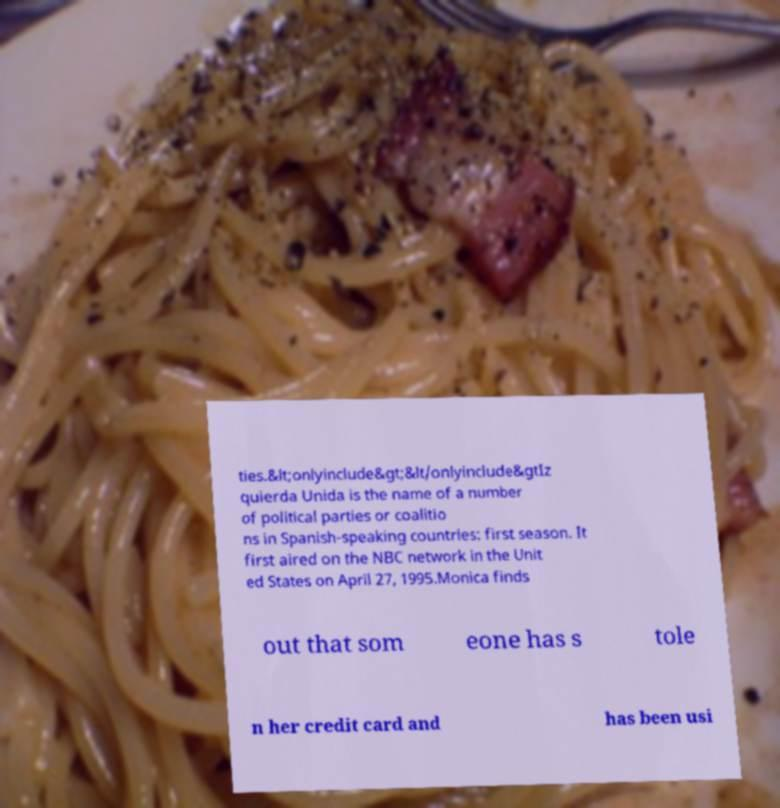Could you assist in decoding the text presented in this image and type it out clearly? ties.&lt;onlyinclude&gt;&lt/onlyinclude&gtIz quierda Unida is the name of a number of political parties or coalitio ns in Spanish-speaking countries: first season. It first aired on the NBC network in the Unit ed States on April 27, 1995.Monica finds out that som eone has s tole n her credit card and has been usi 